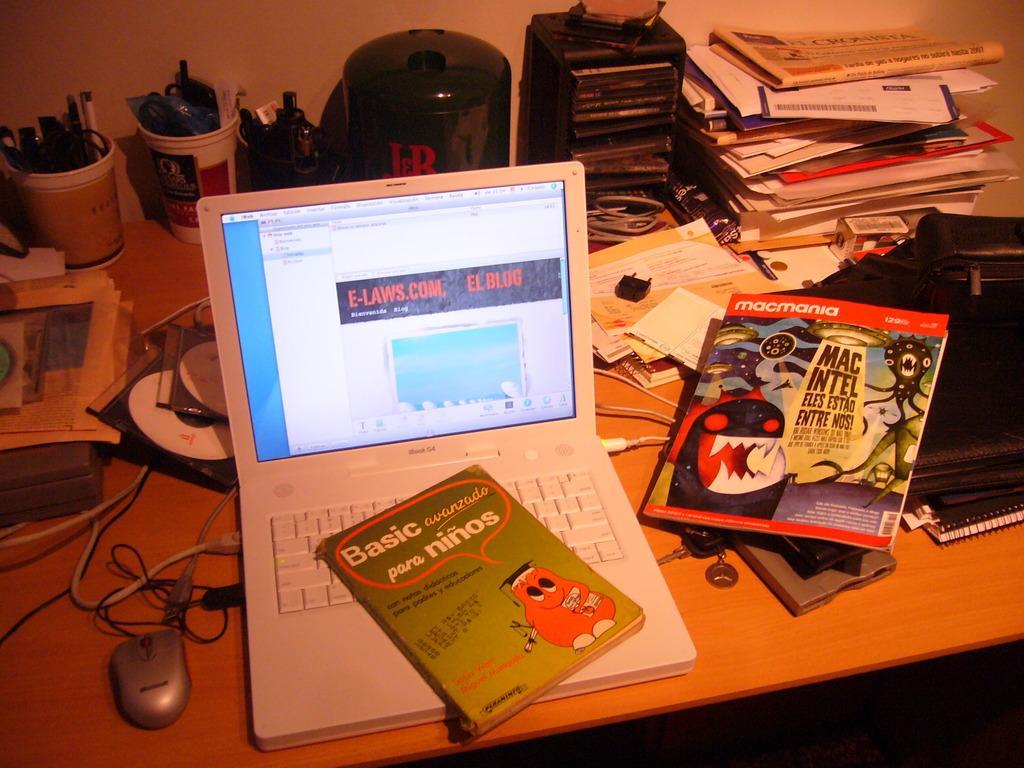How would you summarize this image in a sentence or two? In this image I can see the brown color table. On the table I can see the laptop, books, black color bag, mouse, wires, pens in the cups and few more objects can be see. And there is a wall in the back. 